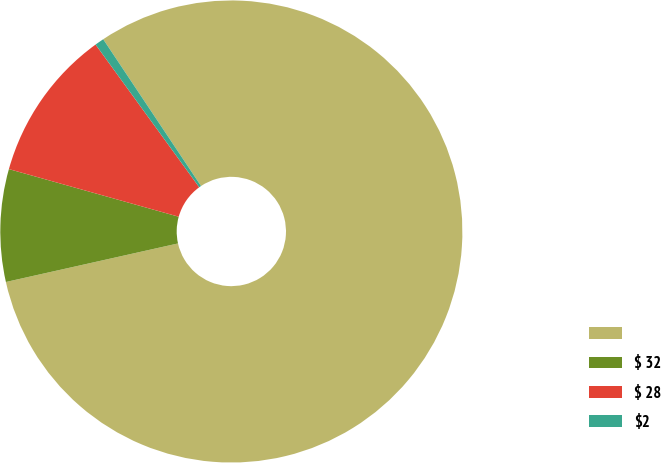Convert chart. <chart><loc_0><loc_0><loc_500><loc_500><pie_chart><ecel><fcel>$ 32<fcel>$ 28<fcel>$2<nl><fcel>80.85%<fcel>7.86%<fcel>10.65%<fcel>0.64%<nl></chart> 